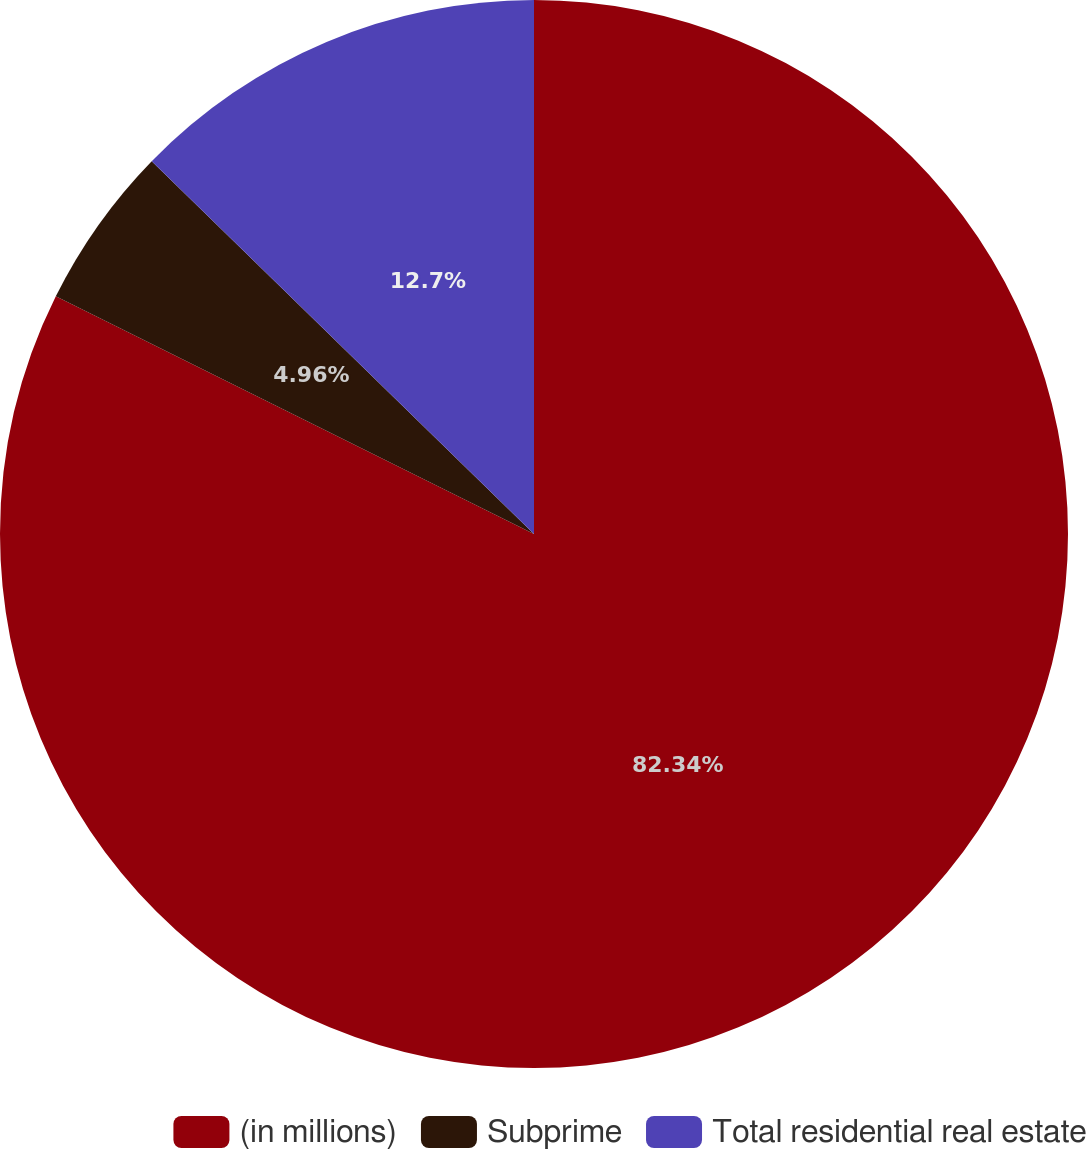<chart> <loc_0><loc_0><loc_500><loc_500><pie_chart><fcel>(in millions)<fcel>Subprime<fcel>Total residential real estate<nl><fcel>82.35%<fcel>4.96%<fcel>12.7%<nl></chart> 